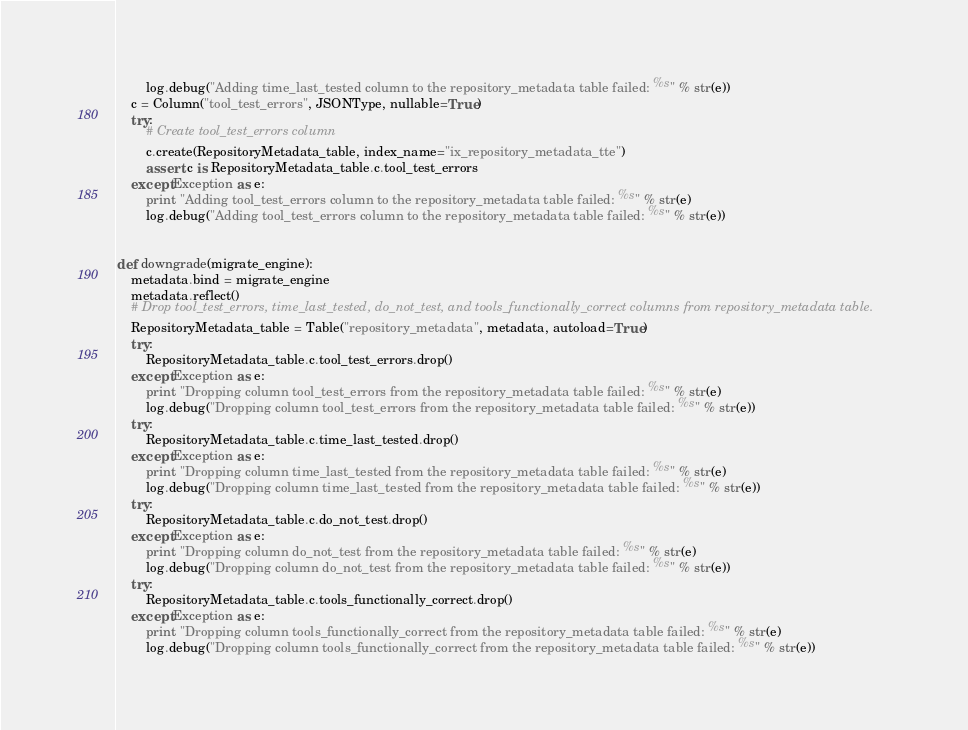<code> <loc_0><loc_0><loc_500><loc_500><_Python_>        log.debug("Adding time_last_tested column to the repository_metadata table failed: %s" % str(e))
    c = Column("tool_test_errors", JSONType, nullable=True)
    try:
        # Create tool_test_errors column
        c.create(RepositoryMetadata_table, index_name="ix_repository_metadata_tte")
        assert c is RepositoryMetadata_table.c.tool_test_errors
    except Exception as e:
        print "Adding tool_test_errors column to the repository_metadata table failed: %s" % str(e)
        log.debug("Adding tool_test_errors column to the repository_metadata table failed: %s" % str(e))


def downgrade(migrate_engine):
    metadata.bind = migrate_engine
    metadata.reflect()
    # Drop tool_test_errors, time_last_tested, do_not_test, and tools_functionally_correct columns from repository_metadata table.
    RepositoryMetadata_table = Table("repository_metadata", metadata, autoload=True)
    try:
        RepositoryMetadata_table.c.tool_test_errors.drop()
    except Exception as e:
        print "Dropping column tool_test_errors from the repository_metadata table failed: %s" % str(e)
        log.debug("Dropping column tool_test_errors from the repository_metadata table failed: %s" % str(e))
    try:
        RepositoryMetadata_table.c.time_last_tested.drop()
    except Exception as e:
        print "Dropping column time_last_tested from the repository_metadata table failed: %s" % str(e)
        log.debug("Dropping column time_last_tested from the repository_metadata table failed: %s" % str(e))
    try:
        RepositoryMetadata_table.c.do_not_test.drop()
    except Exception as e:
        print "Dropping column do_not_test from the repository_metadata table failed: %s" % str(e)
        log.debug("Dropping column do_not_test from the repository_metadata table failed: %s" % str(e))
    try:
        RepositoryMetadata_table.c.tools_functionally_correct.drop()
    except Exception as e:
        print "Dropping column tools_functionally_correct from the repository_metadata table failed: %s" % str(e)
        log.debug("Dropping column tools_functionally_correct from the repository_metadata table failed: %s" % str(e))
</code> 